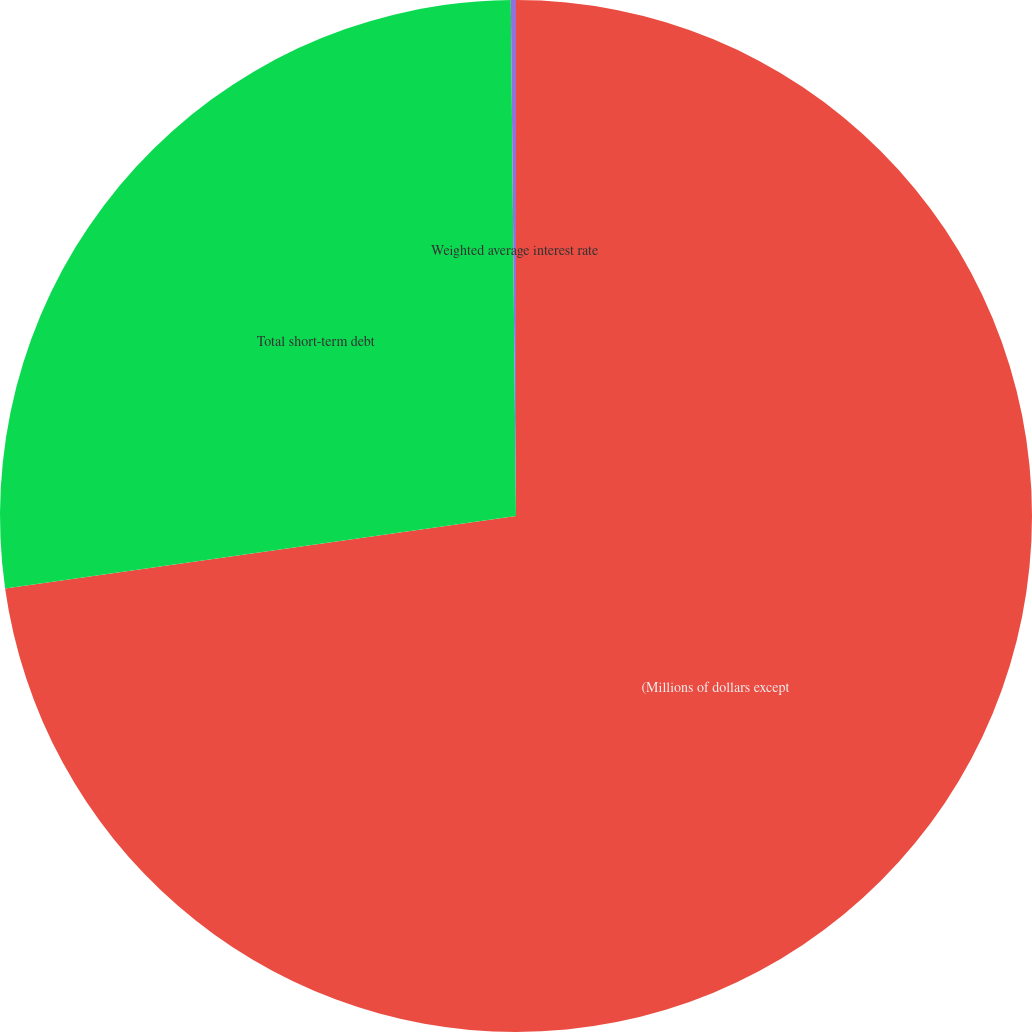Convert chart to OTSL. <chart><loc_0><loc_0><loc_500><loc_500><pie_chart><fcel>(Millions of dollars except<fcel>Total short-term debt<fcel>Weighted average interest rate<nl><fcel>72.76%<fcel>27.08%<fcel>0.16%<nl></chart> 